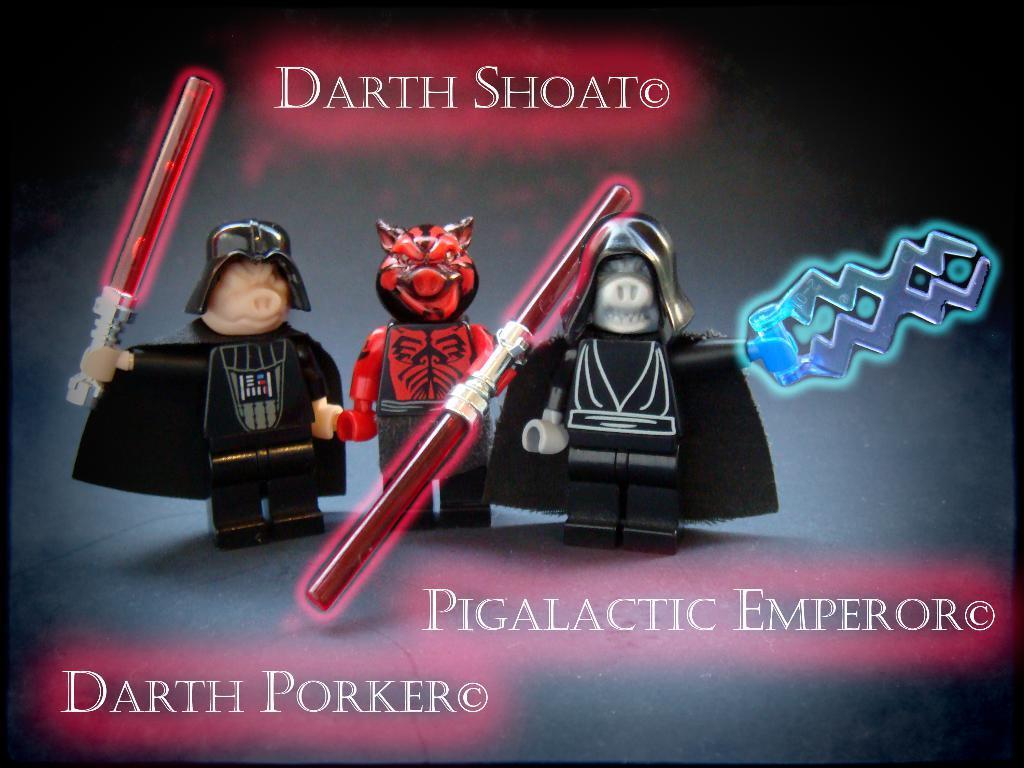Describe this image in one or two sentences. In this image there is a poster with three toys and some text written on it. 